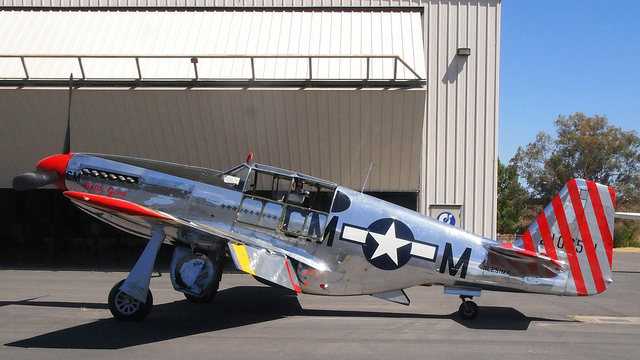Please extract the text content from this image. CM CM M 